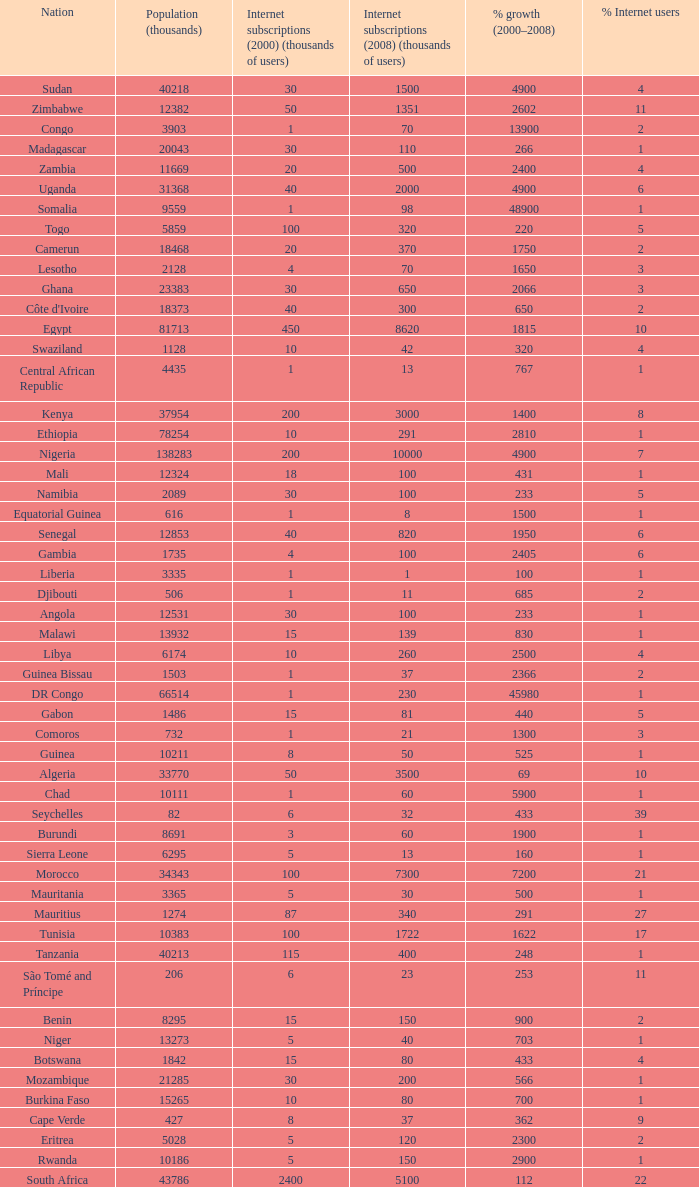What is the percentage of growth in 2000-2008 in ethiopia? 2810.0. I'm looking to parse the entire table for insights. Could you assist me with that? {'header': ['Nation', 'Population (thousands)', 'Internet subscriptions (2000) (thousands of users)', 'Internet subscriptions (2008) (thousands of users)', '% growth (2000–2008)', '% Internet users'], 'rows': [['Sudan', '40218', '30', '1500', '4900', '4'], ['Zimbabwe', '12382', '50', '1351', '2602', '11'], ['Congo', '3903', '1', '70', '13900', '2'], ['Madagascar', '20043', '30', '110', '266', '1'], ['Zambia', '11669', '20', '500', '2400', '4'], ['Uganda', '31368', '40', '2000', '4900', '6'], ['Somalia', '9559', '1', '98', '48900', '1'], ['Togo', '5859', '100', '320', '220', '5'], ['Camerun', '18468', '20', '370', '1750', '2'], ['Lesotho', '2128', '4', '70', '1650', '3'], ['Ghana', '23383', '30', '650', '2066', '3'], ["Côte d'Ivoire", '18373', '40', '300', '650', '2'], ['Egypt', '81713', '450', '8620', '1815', '10'], ['Swaziland', '1128', '10', '42', '320', '4'], ['Central African Republic', '4435', '1', '13', '767', '1'], ['Kenya', '37954', '200', '3000', '1400', '8'], ['Ethiopia', '78254', '10', '291', '2810', '1'], ['Nigeria', '138283', '200', '10000', '4900', '7'], ['Mali', '12324', '18', '100', '431', '1'], ['Namibia', '2089', '30', '100', '233', '5'], ['Equatorial Guinea', '616', '1', '8', '1500', '1'], ['Senegal', '12853', '40', '820', '1950', '6'], ['Gambia', '1735', '4', '100', '2405', '6'], ['Liberia', '3335', '1', '1', '100', '1'], ['Djibouti', '506', '1', '11', '685', '2'], ['Angola', '12531', '30', '100', '233', '1'], ['Malawi', '13932', '15', '139', '830', '1'], ['Libya', '6174', '10', '260', '2500', '4'], ['Guinea Bissau', '1503', '1', '37', '2366', '2'], ['DR Congo', '66514', '1', '230', '45980', '1'], ['Gabon', '1486', '15', '81', '440', '5'], ['Comoros', '732', '1', '21', '1300', '3'], ['Guinea', '10211', '8', '50', '525', '1'], ['Algeria', '33770', '50', '3500', '69', '10'], ['Chad', '10111', '1', '60', '5900', '1'], ['Seychelles', '82', '6', '32', '433', '39'], ['Burundi', '8691', '3', '60', '1900', '1'], ['Sierra Leone', '6295', '5', '13', '160', '1'], ['Morocco', '34343', '100', '7300', '7200', '21'], ['Mauritania', '3365', '5', '30', '500', '1'], ['Mauritius', '1274', '87', '340', '291', '27'], ['Tunisia', '10383', '100', '1722', '1622', '17'], ['Tanzania', '40213', '115', '400', '248', '1'], ['São Tomé and Príncipe', '206', '6', '23', '253', '11'], ['Benin', '8295', '15', '150', '900', '2'], ['Niger', '13273', '5', '40', '703', '1'], ['Botswana', '1842', '15', '80', '433', '4'], ['Mozambique', '21285', '30', '200', '566', '1'], ['Burkina Faso', '15265', '10', '80', '700', '1'], ['Cape Verde', '427', '8', '37', '362', '9'], ['Eritrea', '5028', '5', '120', '2300', '2'], ['Rwanda', '10186', '5', '150', '2900', '1'], ['South Africa', '43786', '2400', '5100', '112', '22']]} 